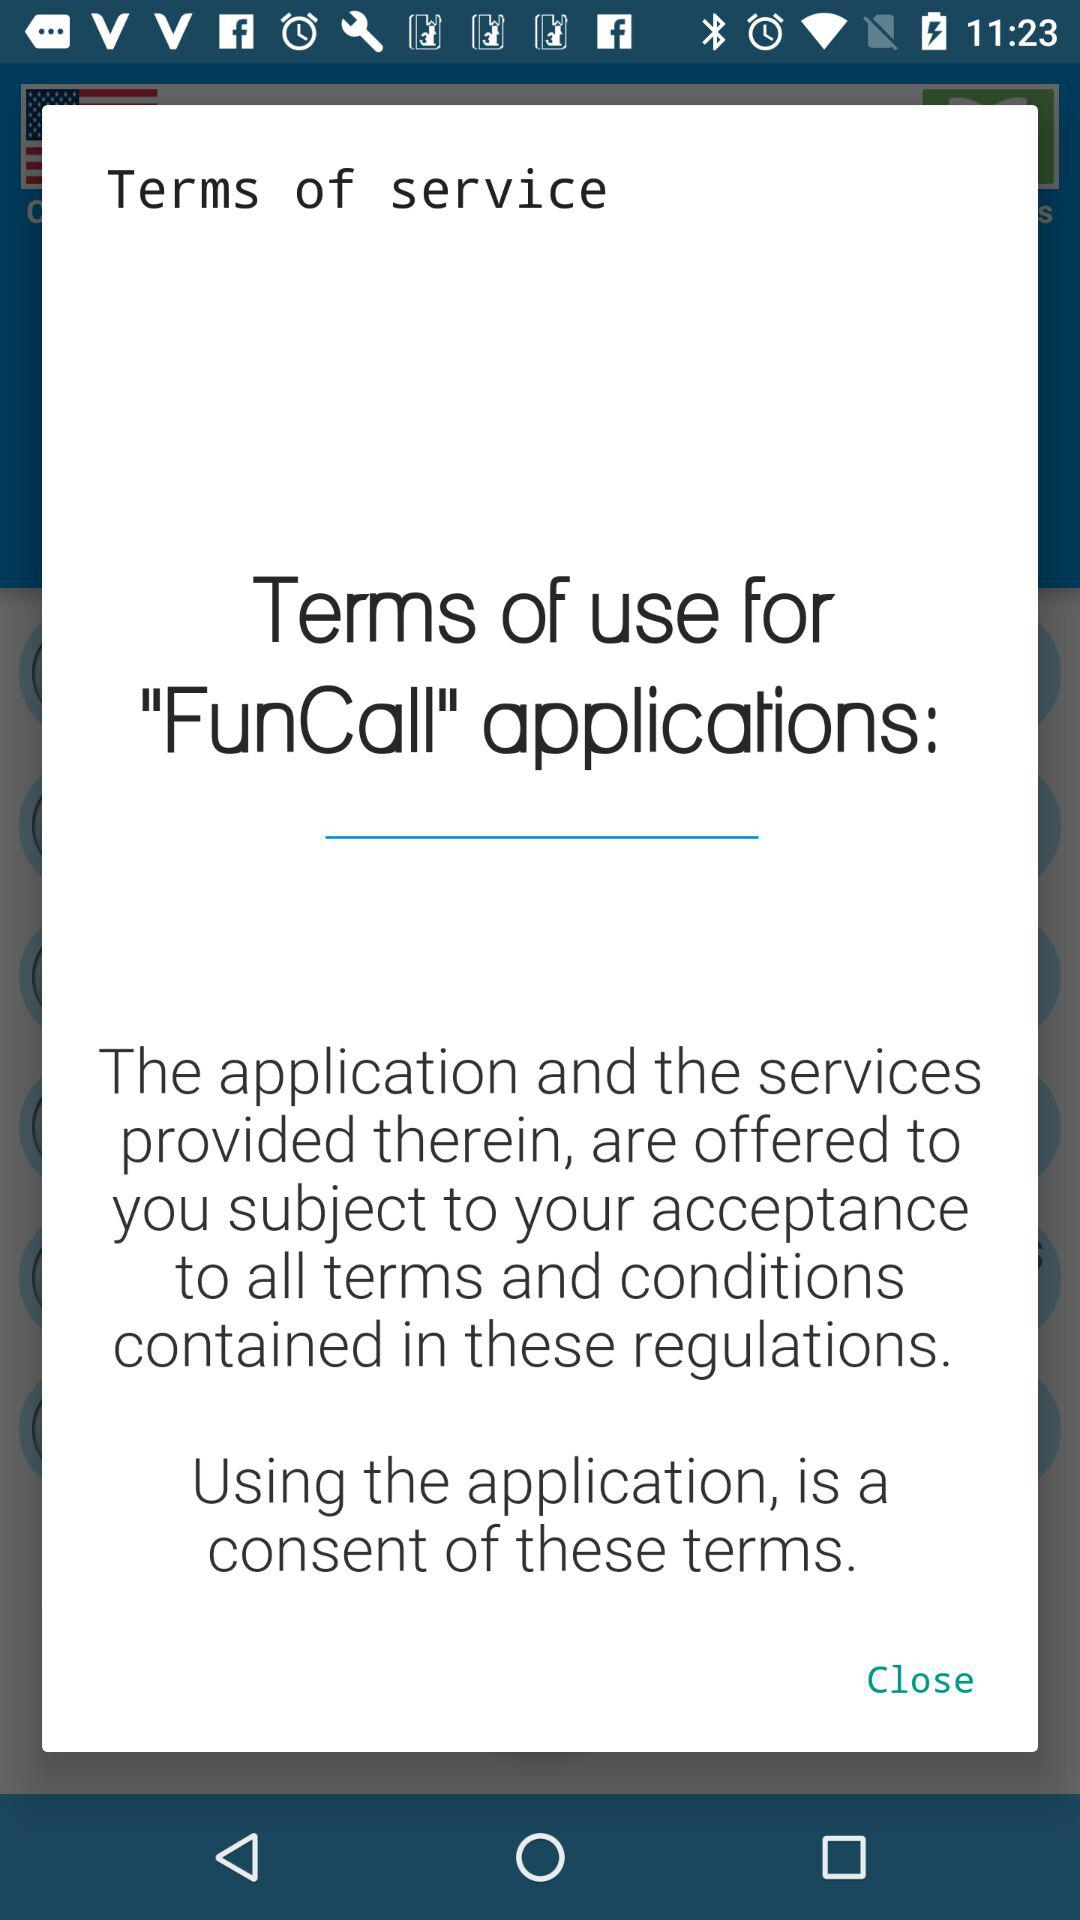What is the username?
When the provided information is insufficient, respond with <no answer>. <no answer> 